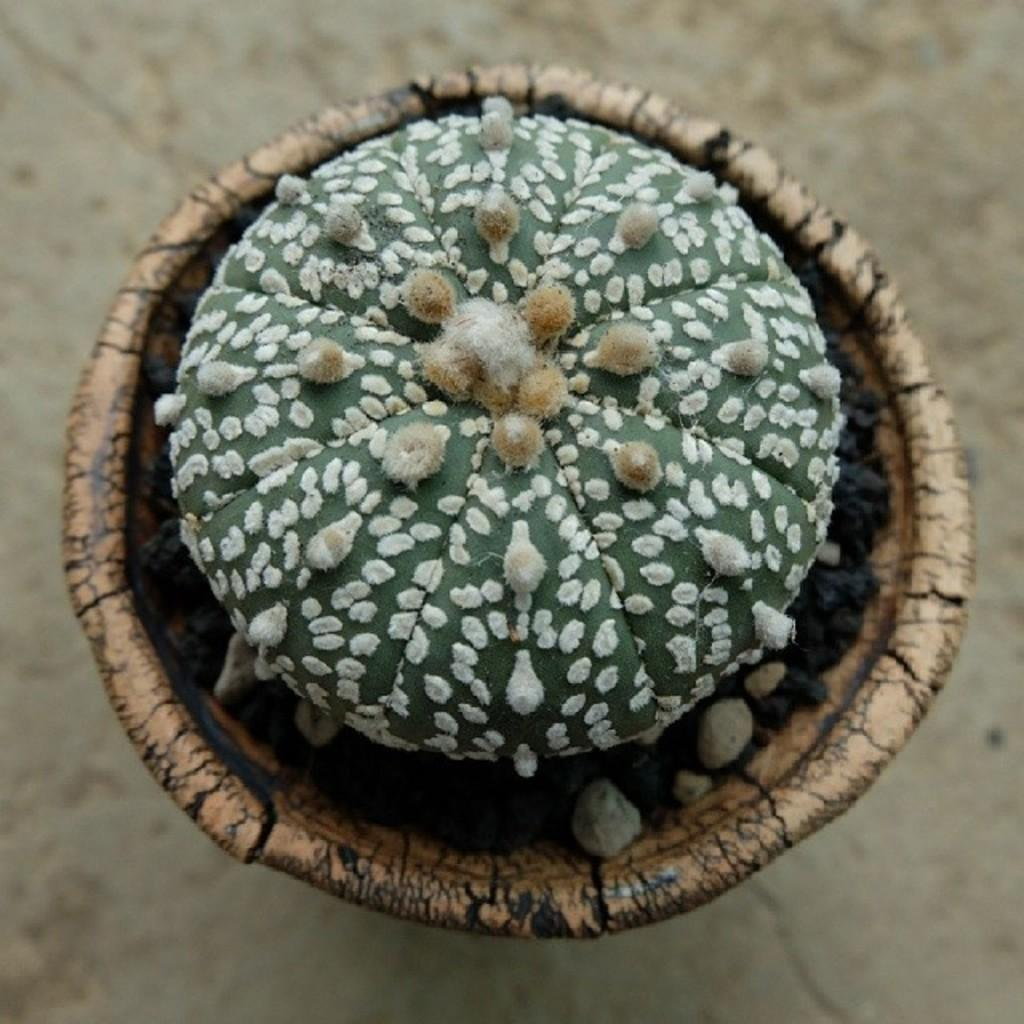What is the main object in the image? There is a pot in the image. What is inside the pot? The pot contains hedgehog cactus. What story is being told by the lake in the image? There is no lake present in the image, so no story can be told by a lake. 